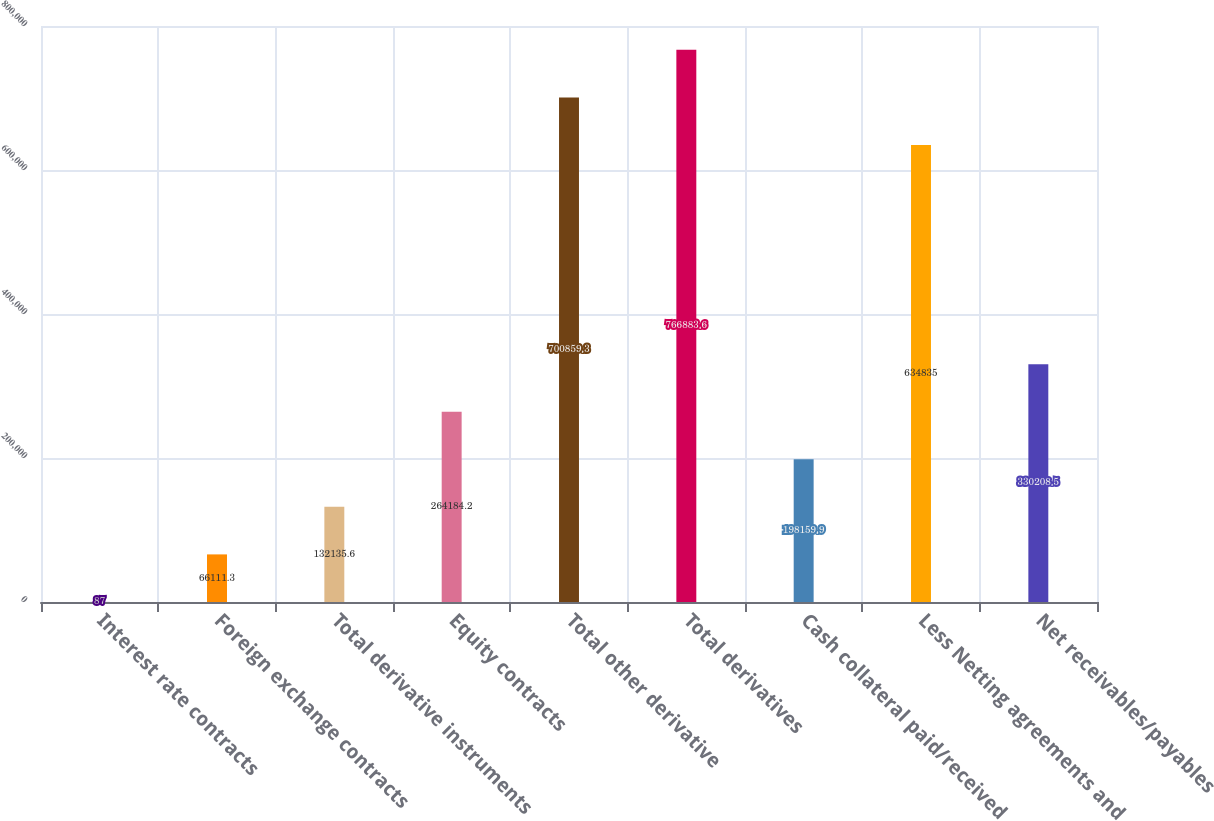Convert chart. <chart><loc_0><loc_0><loc_500><loc_500><bar_chart><fcel>Interest rate contracts<fcel>Foreign exchange contracts<fcel>Total derivative instruments<fcel>Equity contracts<fcel>Total other derivative<fcel>Total derivatives<fcel>Cash collateral paid/received<fcel>Less Netting agreements and<fcel>Net receivables/payables<nl><fcel>87<fcel>66111.3<fcel>132136<fcel>264184<fcel>700859<fcel>766884<fcel>198160<fcel>634835<fcel>330208<nl></chart> 